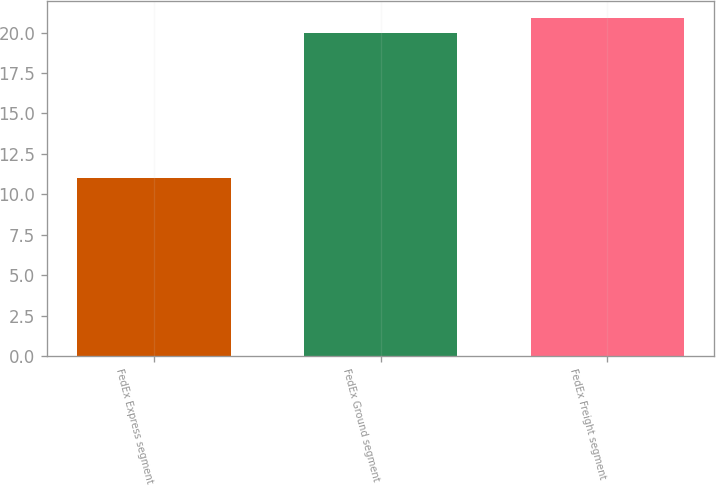Convert chart. <chart><loc_0><loc_0><loc_500><loc_500><bar_chart><fcel>FedEx Express segment<fcel>FedEx Ground segment<fcel>FedEx Freight segment<nl><fcel>11<fcel>20<fcel>20.9<nl></chart> 